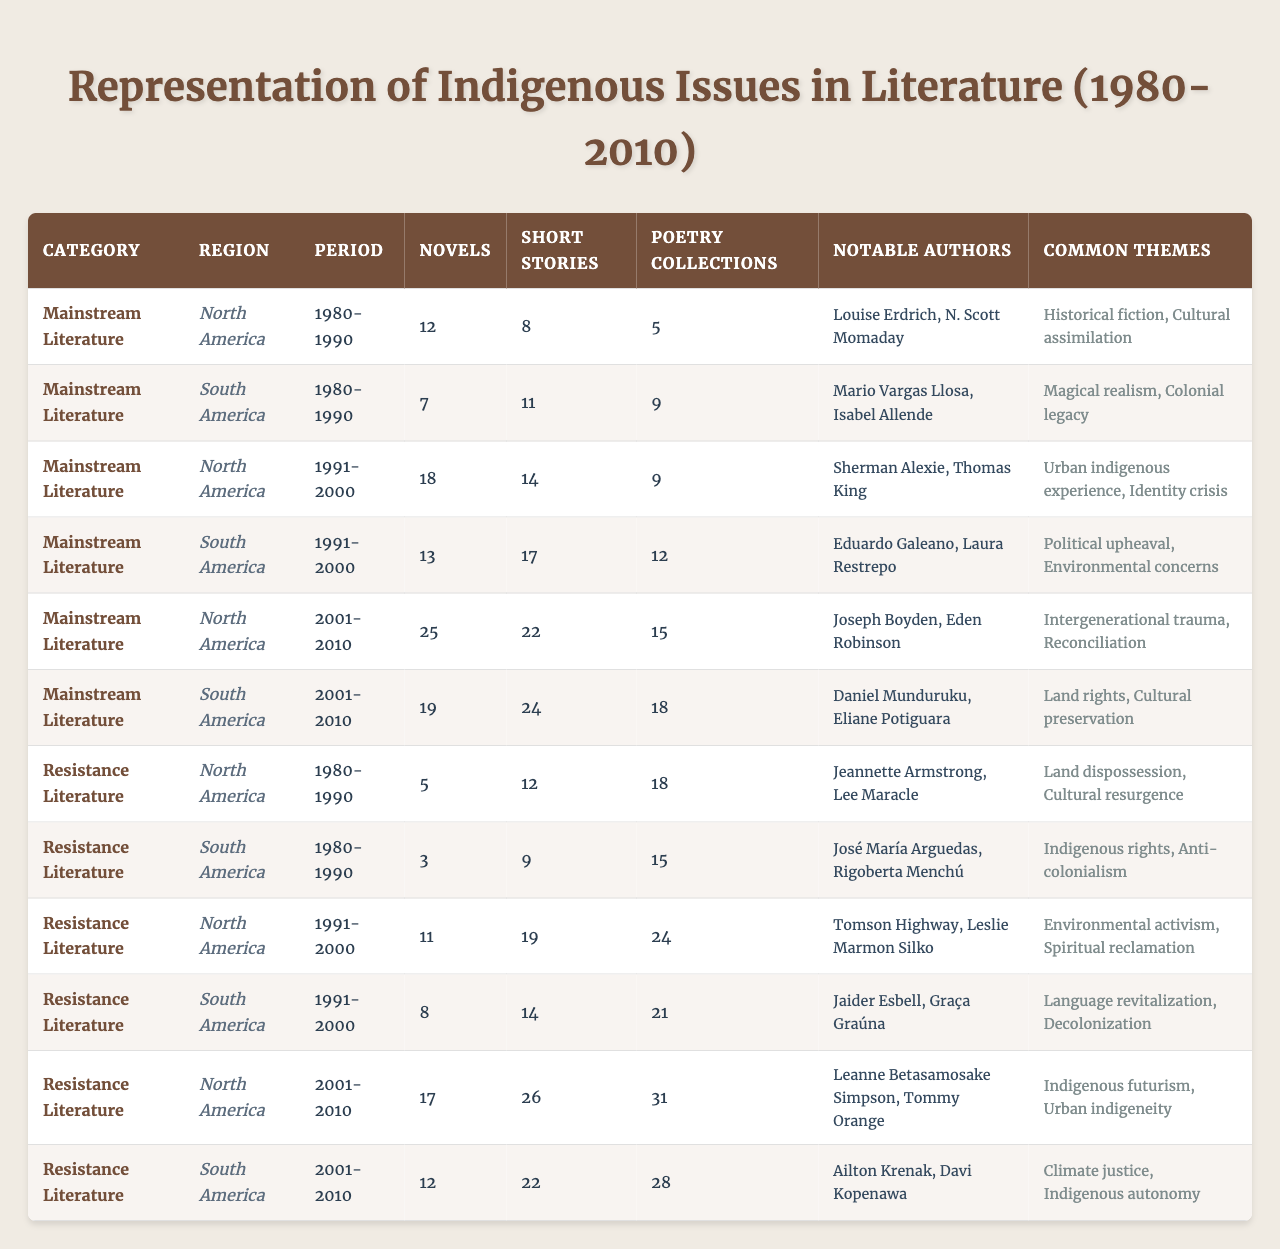What is the total number of novels published in North America from resistance literature during 2001-2010? According to the table, there are 17 novels published in North America from resistance literature during the period of 2001-2010.
Answer: 17 How many poetry collections are found in mainstream literature from South America in the 1991-2000 period? The table indicates that there are 12 poetry collections in mainstream literature from South America during 1991-2000.
Answer: 12 Which notable authors are associated with South American mainstream literature in the 1980-1990 period? The table lists Mario Vargas Llosa and Isabel Allende as notable authors in South American mainstream literature during 1980-1990.
Answer: Mario Vargas Llosa, Isabel Allende In which decade did North American resistance literature see the highest number of short stories? From the table, North American resistance literature had its highest number of short stories (26) during the period of 2001-2010.
Answer: 2001-2010 What is the difference in the number of novels between mainstream and resistance literature in South America during 1991-2000? Mainstream literature had 13 novels and resistance literature had 8 novels in South America during 1991-2000. The difference is 13 - 8 = 5.
Answer: 5 True or False: The common themes for mainstream literature in North America from 2001-2010 include "climate justice." The themes listed for North American mainstream literature in 2001-2010 are "Intergenerational trauma" and "Reconciliation," which do not include "climate justice."
Answer: False What is the average number of poetry collections published in North America across all periods in resistance literature? Adding the numbers of poetry collections from resistance literature in North America: 18 (1980-1990) + 24 (1991-2000) + 31 (2001-2010) = 73. There are 3 periods, so the average is 73 / 3 ≈ 24.33.
Answer: Approximately 24.33 Identify the authors associated with resistance literature in South America during the 1980-1990 period and summarize their common themes. The authors listed are José María Arguedas and Rigoberta Menchú, and their common themes include "Indigenous rights" and "Anti-colonialism."
Answer: José María Arguedas, Rigoberta Menchú; Indigenous rights, Anti-colonialism Which region and category had the lowest number of short stories in the 1980-1990 period? In the 1980-1990 period, South America in the mainstream literature category had 11 short stories, while the lowest in resistance literature was North America with 12 short stories. Therefore, South America in mainstream literature had the lowest.
Answer: South America in mainstream literature Calculate the total number of literary works (novels, short stories, poetry collections) from North American resistance literature across all periods. Adding the totals: 5 + 12 + 18 (1980-1990) + 11 + 19 + 24 (1991-2000) + 17 + 26 + 31 (2001-2010) = 166.
Answer: 166 